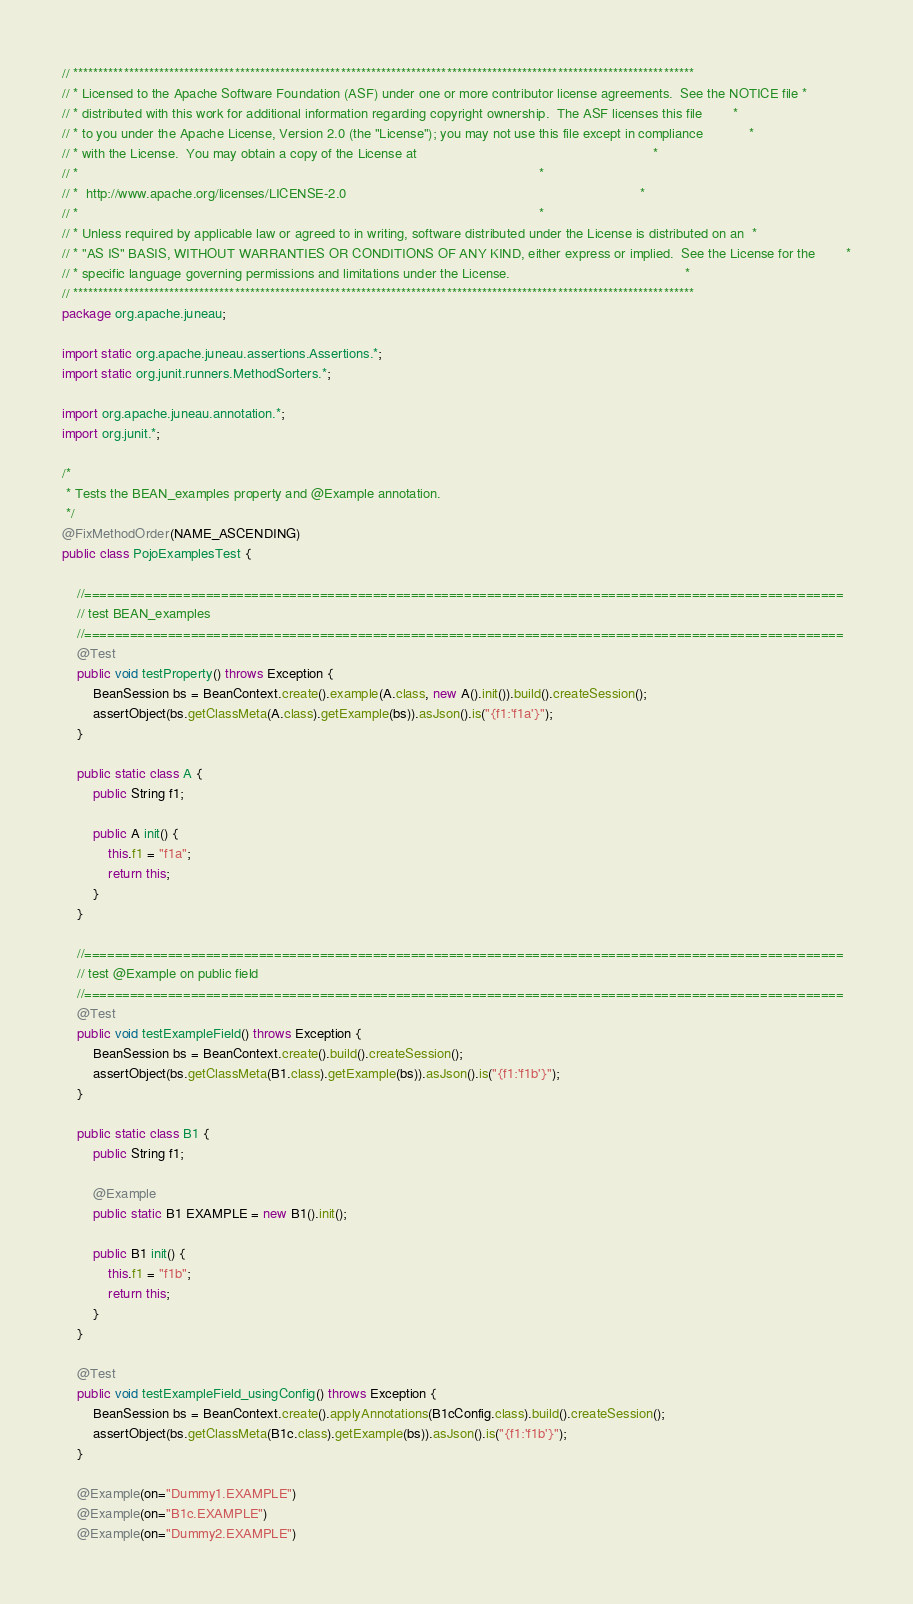Convert code to text. <code><loc_0><loc_0><loc_500><loc_500><_Java_>// ***************************************************************************************************************************
// * Licensed to the Apache Software Foundation (ASF) under one or more contributor license agreements.  See the NOTICE file *
// * distributed with this work for additional information regarding copyright ownership.  The ASF licenses this file        *
// * to you under the Apache License, Version 2.0 (the "License"); you may not use this file except in compliance            *
// * with the License.  You may obtain a copy of the License at                                                              *
// *                                                                                                                         *
// *  http://www.apache.org/licenses/LICENSE-2.0                                                                             *
// *                                                                                                                         *
// * Unless required by applicable law or agreed to in writing, software distributed under the License is distributed on an  *
// * "AS IS" BASIS, WITHOUT WARRANTIES OR CONDITIONS OF ANY KIND, either express or implied.  See the License for the        *
// * specific language governing permissions and limitations under the License.                                              *
// ***************************************************************************************************************************
package org.apache.juneau;

import static org.apache.juneau.assertions.Assertions.*;
import static org.junit.runners.MethodSorters.*;

import org.apache.juneau.annotation.*;
import org.junit.*;

/*
 * Tests the BEAN_examples property and @Example annotation.
 */
@FixMethodOrder(NAME_ASCENDING)
public class PojoExamplesTest {

	//====================================================================================================
	// test BEAN_examples
	//====================================================================================================
	@Test
	public void testProperty() throws Exception {
		BeanSession bs = BeanContext.create().example(A.class, new A().init()).build().createSession();
		assertObject(bs.getClassMeta(A.class).getExample(bs)).asJson().is("{f1:'f1a'}");
	}

	public static class A {
		public String f1;

		public A init() {
			this.f1 = "f1a";
			return this;
		}
	}

	//====================================================================================================
	// test @Example on public field
	//====================================================================================================
	@Test
	public void testExampleField() throws Exception {
		BeanSession bs = BeanContext.create().build().createSession();
		assertObject(bs.getClassMeta(B1.class).getExample(bs)).asJson().is("{f1:'f1b'}");
	}

	public static class B1 {
		public String f1;

		@Example
		public static B1 EXAMPLE = new B1().init();

		public B1 init() {
			this.f1 = "f1b";
			return this;
		}
	}

	@Test
	public void testExampleField_usingConfig() throws Exception {
		BeanSession bs = BeanContext.create().applyAnnotations(B1cConfig.class).build().createSession();
		assertObject(bs.getClassMeta(B1c.class).getExample(bs)).asJson().is("{f1:'f1b'}");
	}

	@Example(on="Dummy1.EXAMPLE")
	@Example(on="B1c.EXAMPLE")
	@Example(on="Dummy2.EXAMPLE")</code> 